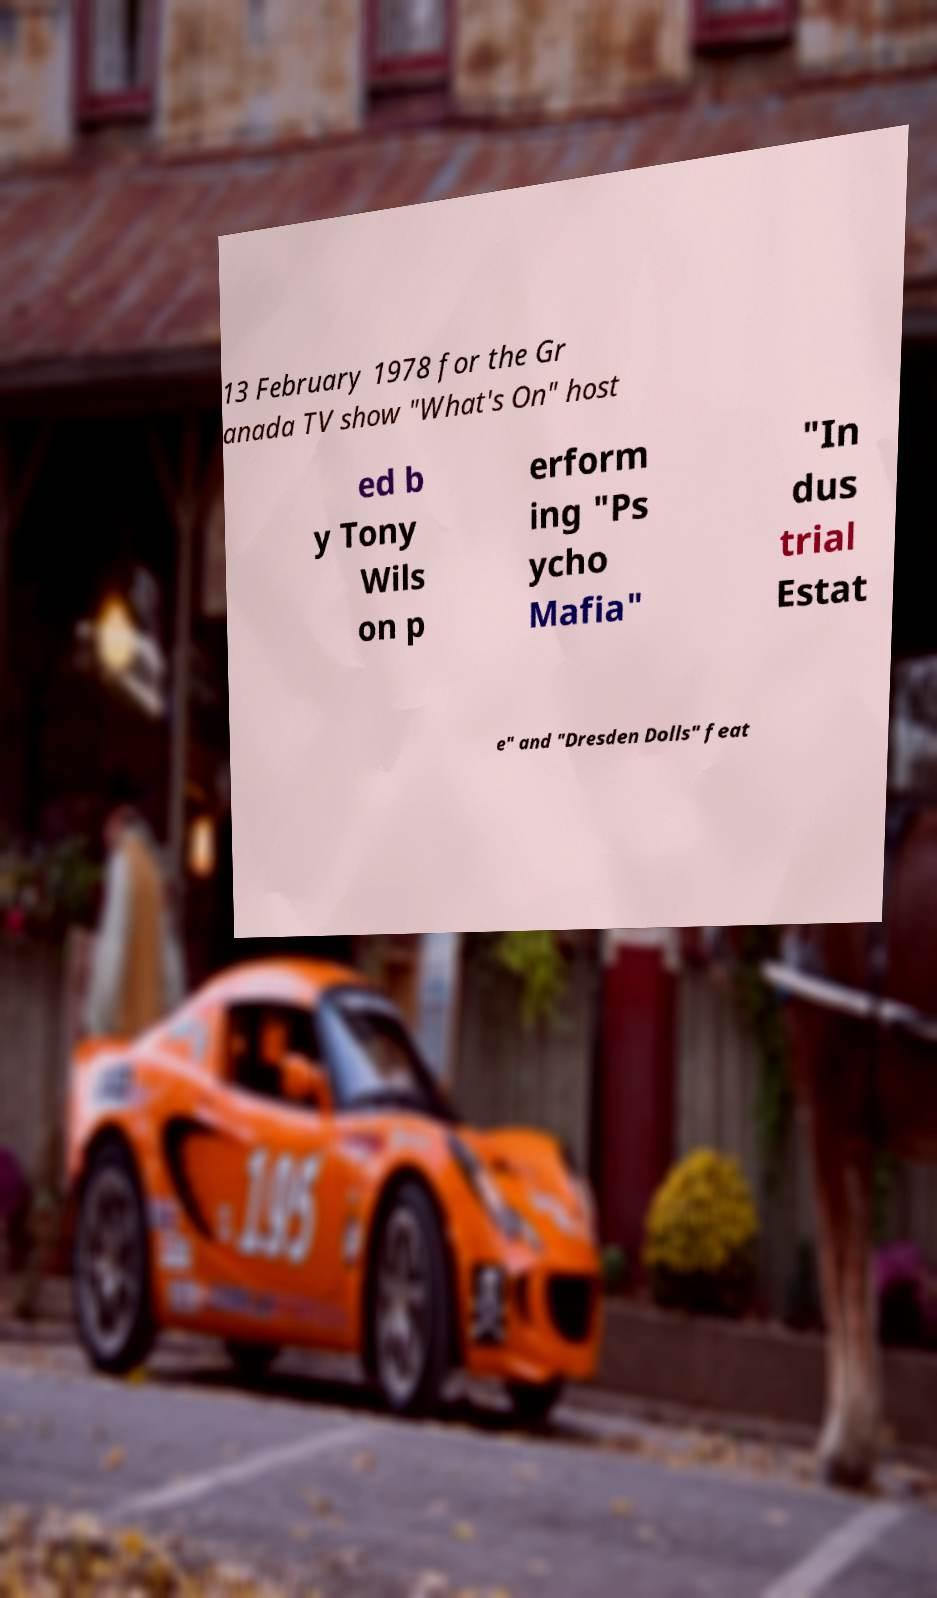Could you assist in decoding the text presented in this image and type it out clearly? 13 February 1978 for the Gr anada TV show "What's On" host ed b y Tony Wils on p erform ing "Ps ycho Mafia" "In dus trial Estat e" and "Dresden Dolls" feat 